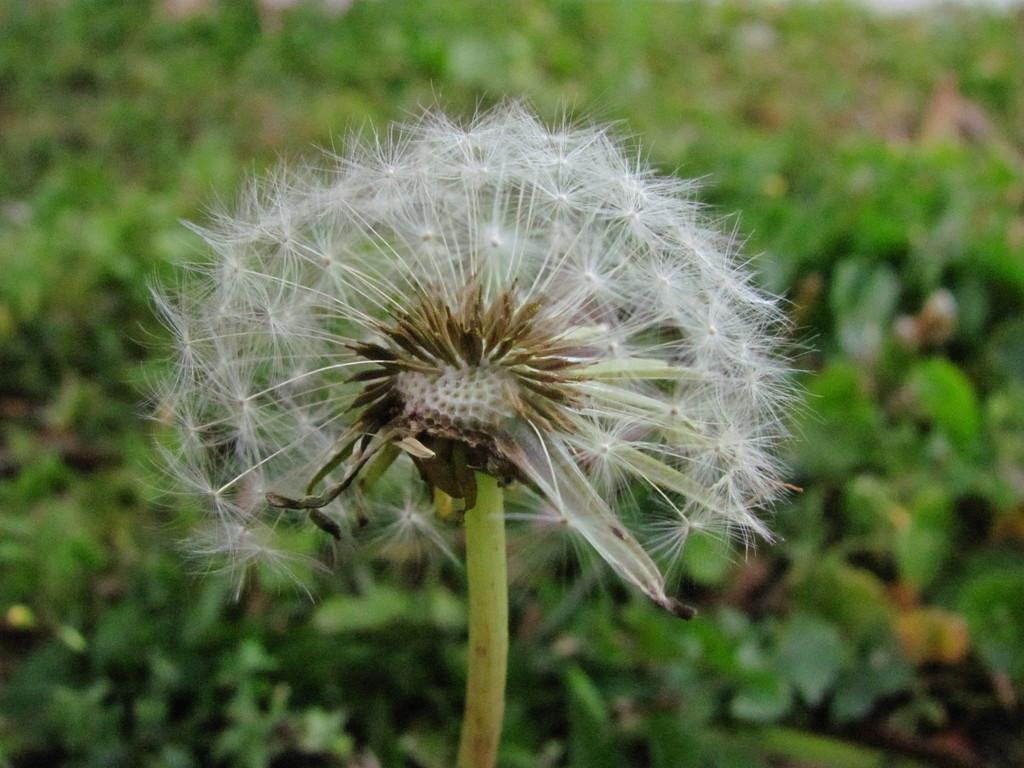What type of living organisms can be seen in the image? Plants can be seen in the image. Can you describe the background of the image? The background of the image is blurred. What type of process is being performed in the hospital in the image? There is no hospital or process present in the image; it only features plants and a blurred background. 